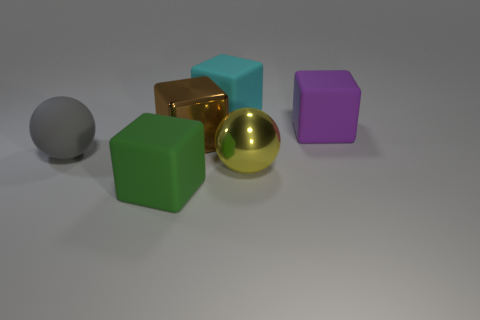Are there any big yellow shiny balls behind the purple matte thing?
Keep it short and to the point. No. Is there a tiny yellow rubber thing of the same shape as the yellow shiny object?
Ensure brevity in your answer.  No. Do the metal thing in front of the brown object and the shiny thing that is behind the yellow metallic ball have the same shape?
Give a very brief answer. No. Is there a cyan metal cylinder of the same size as the green rubber cube?
Provide a succinct answer. No. Are there the same number of brown metal things behind the purple rubber object and matte objects in front of the green block?
Offer a very short reply. Yes. Is the ball that is on the right side of the matte sphere made of the same material as the big cube that is to the right of the cyan cube?
Give a very brief answer. No. What is the material of the gray ball?
Keep it short and to the point. Rubber. What number of other objects are the same color as the large rubber ball?
Your answer should be compact. 0. Does the large rubber ball have the same color as the metal ball?
Your answer should be very brief. No. What number of purple matte cubes are there?
Offer a very short reply. 1. 